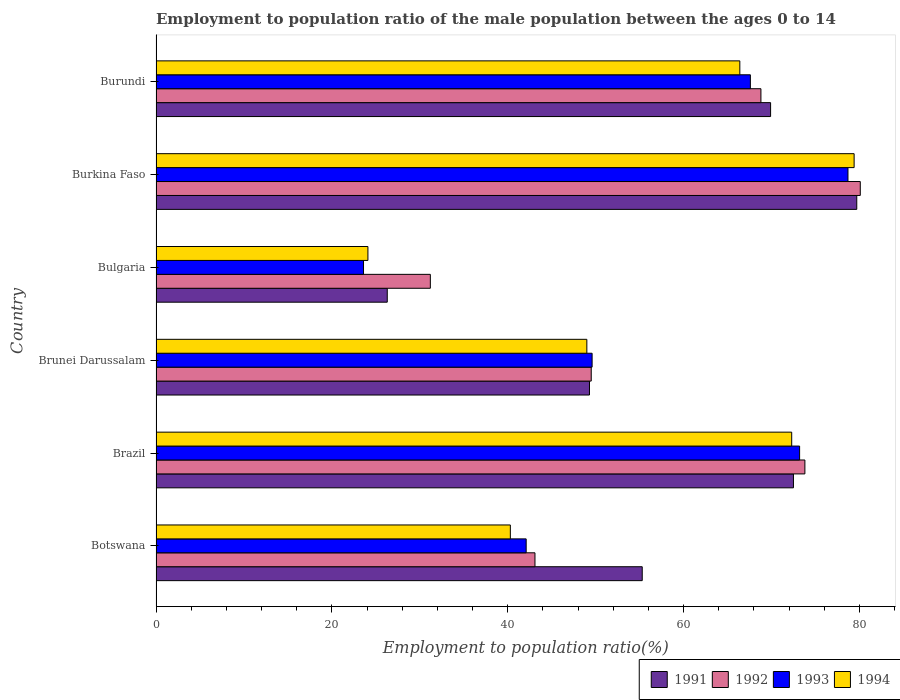Are the number of bars per tick equal to the number of legend labels?
Your answer should be very brief. Yes. How many bars are there on the 2nd tick from the top?
Offer a very short reply. 4. In how many cases, is the number of bars for a given country not equal to the number of legend labels?
Give a very brief answer. 0. What is the employment to population ratio in 1994 in Burundi?
Offer a very short reply. 66.4. Across all countries, what is the maximum employment to population ratio in 1991?
Your answer should be compact. 79.7. Across all countries, what is the minimum employment to population ratio in 1994?
Your response must be concise. 24.1. In which country was the employment to population ratio in 1994 maximum?
Your response must be concise. Burkina Faso. What is the total employment to population ratio in 1992 in the graph?
Offer a terse response. 346.5. What is the difference between the employment to population ratio in 1992 in Bulgaria and that in Burkina Faso?
Offer a very short reply. -48.9. What is the difference between the employment to population ratio in 1994 in Botswana and the employment to population ratio in 1992 in Brazil?
Offer a terse response. -33.5. What is the average employment to population ratio in 1992 per country?
Offer a very short reply. 57.75. What is the difference between the employment to population ratio in 1992 and employment to population ratio in 1994 in Burkina Faso?
Make the answer very short. 0.7. In how many countries, is the employment to population ratio in 1994 greater than 16 %?
Ensure brevity in your answer.  6. What is the ratio of the employment to population ratio in 1994 in Burkina Faso to that in Burundi?
Your response must be concise. 1.2. Is the employment to population ratio in 1993 in Botswana less than that in Bulgaria?
Your response must be concise. No. What is the difference between the highest and the second highest employment to population ratio in 1992?
Ensure brevity in your answer.  6.3. What is the difference between the highest and the lowest employment to population ratio in 1992?
Provide a short and direct response. 48.9. Is the sum of the employment to population ratio in 1994 in Brunei Darussalam and Burundi greater than the maximum employment to population ratio in 1992 across all countries?
Provide a short and direct response. Yes. What does the 2nd bar from the bottom in Brunei Darussalam represents?
Keep it short and to the point. 1992. Is it the case that in every country, the sum of the employment to population ratio in 1992 and employment to population ratio in 1994 is greater than the employment to population ratio in 1993?
Make the answer very short. Yes. How many bars are there?
Give a very brief answer. 24. How many countries are there in the graph?
Keep it short and to the point. 6. Are the values on the major ticks of X-axis written in scientific E-notation?
Make the answer very short. No. Does the graph contain any zero values?
Your response must be concise. No. Does the graph contain grids?
Offer a very short reply. No. Where does the legend appear in the graph?
Provide a short and direct response. Bottom right. How many legend labels are there?
Ensure brevity in your answer.  4. How are the legend labels stacked?
Your answer should be very brief. Horizontal. What is the title of the graph?
Your answer should be very brief. Employment to population ratio of the male population between the ages 0 to 14. Does "1969" appear as one of the legend labels in the graph?
Make the answer very short. No. What is the label or title of the Y-axis?
Offer a very short reply. Country. What is the Employment to population ratio(%) in 1991 in Botswana?
Make the answer very short. 55.3. What is the Employment to population ratio(%) in 1992 in Botswana?
Make the answer very short. 43.1. What is the Employment to population ratio(%) in 1993 in Botswana?
Ensure brevity in your answer.  42.1. What is the Employment to population ratio(%) of 1994 in Botswana?
Your answer should be very brief. 40.3. What is the Employment to population ratio(%) in 1991 in Brazil?
Your response must be concise. 72.5. What is the Employment to population ratio(%) in 1992 in Brazil?
Your answer should be compact. 73.8. What is the Employment to population ratio(%) of 1993 in Brazil?
Your answer should be very brief. 73.2. What is the Employment to population ratio(%) of 1994 in Brazil?
Ensure brevity in your answer.  72.3. What is the Employment to population ratio(%) in 1991 in Brunei Darussalam?
Provide a short and direct response. 49.3. What is the Employment to population ratio(%) of 1992 in Brunei Darussalam?
Offer a very short reply. 49.5. What is the Employment to population ratio(%) of 1993 in Brunei Darussalam?
Your answer should be very brief. 49.6. What is the Employment to population ratio(%) in 1994 in Brunei Darussalam?
Give a very brief answer. 49. What is the Employment to population ratio(%) in 1991 in Bulgaria?
Your answer should be very brief. 26.3. What is the Employment to population ratio(%) in 1992 in Bulgaria?
Make the answer very short. 31.2. What is the Employment to population ratio(%) in 1993 in Bulgaria?
Your response must be concise. 23.6. What is the Employment to population ratio(%) of 1994 in Bulgaria?
Your response must be concise. 24.1. What is the Employment to population ratio(%) of 1991 in Burkina Faso?
Provide a succinct answer. 79.7. What is the Employment to population ratio(%) in 1992 in Burkina Faso?
Keep it short and to the point. 80.1. What is the Employment to population ratio(%) of 1993 in Burkina Faso?
Keep it short and to the point. 78.7. What is the Employment to population ratio(%) in 1994 in Burkina Faso?
Make the answer very short. 79.4. What is the Employment to population ratio(%) of 1991 in Burundi?
Make the answer very short. 69.9. What is the Employment to population ratio(%) in 1992 in Burundi?
Offer a terse response. 68.8. What is the Employment to population ratio(%) in 1993 in Burundi?
Give a very brief answer. 67.6. What is the Employment to population ratio(%) of 1994 in Burundi?
Ensure brevity in your answer.  66.4. Across all countries, what is the maximum Employment to population ratio(%) in 1991?
Ensure brevity in your answer.  79.7. Across all countries, what is the maximum Employment to population ratio(%) of 1992?
Your answer should be very brief. 80.1. Across all countries, what is the maximum Employment to population ratio(%) of 1993?
Your response must be concise. 78.7. Across all countries, what is the maximum Employment to population ratio(%) in 1994?
Keep it short and to the point. 79.4. Across all countries, what is the minimum Employment to population ratio(%) of 1991?
Make the answer very short. 26.3. Across all countries, what is the minimum Employment to population ratio(%) of 1992?
Your answer should be compact. 31.2. Across all countries, what is the minimum Employment to population ratio(%) of 1993?
Offer a very short reply. 23.6. Across all countries, what is the minimum Employment to population ratio(%) of 1994?
Give a very brief answer. 24.1. What is the total Employment to population ratio(%) of 1991 in the graph?
Give a very brief answer. 353. What is the total Employment to population ratio(%) of 1992 in the graph?
Provide a short and direct response. 346.5. What is the total Employment to population ratio(%) of 1993 in the graph?
Your response must be concise. 334.8. What is the total Employment to population ratio(%) in 1994 in the graph?
Your response must be concise. 331.5. What is the difference between the Employment to population ratio(%) of 1991 in Botswana and that in Brazil?
Your response must be concise. -17.2. What is the difference between the Employment to population ratio(%) of 1992 in Botswana and that in Brazil?
Provide a succinct answer. -30.7. What is the difference between the Employment to population ratio(%) in 1993 in Botswana and that in Brazil?
Your answer should be compact. -31.1. What is the difference between the Employment to population ratio(%) in 1994 in Botswana and that in Brazil?
Offer a terse response. -32. What is the difference between the Employment to population ratio(%) in 1991 in Botswana and that in Brunei Darussalam?
Give a very brief answer. 6. What is the difference between the Employment to population ratio(%) in 1992 in Botswana and that in Brunei Darussalam?
Your answer should be very brief. -6.4. What is the difference between the Employment to population ratio(%) in 1994 in Botswana and that in Brunei Darussalam?
Your answer should be compact. -8.7. What is the difference between the Employment to population ratio(%) in 1991 in Botswana and that in Bulgaria?
Keep it short and to the point. 29. What is the difference between the Employment to population ratio(%) in 1992 in Botswana and that in Bulgaria?
Offer a terse response. 11.9. What is the difference between the Employment to population ratio(%) in 1993 in Botswana and that in Bulgaria?
Provide a short and direct response. 18.5. What is the difference between the Employment to population ratio(%) in 1991 in Botswana and that in Burkina Faso?
Provide a short and direct response. -24.4. What is the difference between the Employment to population ratio(%) in 1992 in Botswana and that in Burkina Faso?
Keep it short and to the point. -37. What is the difference between the Employment to population ratio(%) of 1993 in Botswana and that in Burkina Faso?
Your response must be concise. -36.6. What is the difference between the Employment to population ratio(%) in 1994 in Botswana and that in Burkina Faso?
Offer a terse response. -39.1. What is the difference between the Employment to population ratio(%) of 1991 in Botswana and that in Burundi?
Your answer should be compact. -14.6. What is the difference between the Employment to population ratio(%) in 1992 in Botswana and that in Burundi?
Provide a succinct answer. -25.7. What is the difference between the Employment to population ratio(%) of 1993 in Botswana and that in Burundi?
Give a very brief answer. -25.5. What is the difference between the Employment to population ratio(%) in 1994 in Botswana and that in Burundi?
Ensure brevity in your answer.  -26.1. What is the difference between the Employment to population ratio(%) in 1991 in Brazil and that in Brunei Darussalam?
Provide a succinct answer. 23.2. What is the difference between the Employment to population ratio(%) in 1992 in Brazil and that in Brunei Darussalam?
Ensure brevity in your answer.  24.3. What is the difference between the Employment to population ratio(%) in 1993 in Brazil and that in Brunei Darussalam?
Your response must be concise. 23.6. What is the difference between the Employment to population ratio(%) of 1994 in Brazil and that in Brunei Darussalam?
Provide a short and direct response. 23.3. What is the difference between the Employment to population ratio(%) of 1991 in Brazil and that in Bulgaria?
Keep it short and to the point. 46.2. What is the difference between the Employment to population ratio(%) of 1992 in Brazil and that in Bulgaria?
Your answer should be very brief. 42.6. What is the difference between the Employment to population ratio(%) in 1993 in Brazil and that in Bulgaria?
Offer a very short reply. 49.6. What is the difference between the Employment to population ratio(%) in 1994 in Brazil and that in Bulgaria?
Your answer should be very brief. 48.2. What is the difference between the Employment to population ratio(%) in 1992 in Brazil and that in Burkina Faso?
Your answer should be very brief. -6.3. What is the difference between the Employment to population ratio(%) in 1993 in Brazil and that in Burkina Faso?
Your response must be concise. -5.5. What is the difference between the Employment to population ratio(%) of 1991 in Brazil and that in Burundi?
Your answer should be very brief. 2.6. What is the difference between the Employment to population ratio(%) in 1994 in Brazil and that in Burundi?
Make the answer very short. 5.9. What is the difference between the Employment to population ratio(%) of 1991 in Brunei Darussalam and that in Bulgaria?
Offer a terse response. 23. What is the difference between the Employment to population ratio(%) in 1993 in Brunei Darussalam and that in Bulgaria?
Your answer should be compact. 26. What is the difference between the Employment to population ratio(%) in 1994 in Brunei Darussalam and that in Bulgaria?
Provide a succinct answer. 24.9. What is the difference between the Employment to population ratio(%) in 1991 in Brunei Darussalam and that in Burkina Faso?
Ensure brevity in your answer.  -30.4. What is the difference between the Employment to population ratio(%) in 1992 in Brunei Darussalam and that in Burkina Faso?
Make the answer very short. -30.6. What is the difference between the Employment to population ratio(%) in 1993 in Brunei Darussalam and that in Burkina Faso?
Your answer should be very brief. -29.1. What is the difference between the Employment to population ratio(%) in 1994 in Brunei Darussalam and that in Burkina Faso?
Your answer should be compact. -30.4. What is the difference between the Employment to population ratio(%) in 1991 in Brunei Darussalam and that in Burundi?
Your response must be concise. -20.6. What is the difference between the Employment to population ratio(%) in 1992 in Brunei Darussalam and that in Burundi?
Offer a very short reply. -19.3. What is the difference between the Employment to population ratio(%) of 1993 in Brunei Darussalam and that in Burundi?
Offer a very short reply. -18. What is the difference between the Employment to population ratio(%) of 1994 in Brunei Darussalam and that in Burundi?
Provide a short and direct response. -17.4. What is the difference between the Employment to population ratio(%) of 1991 in Bulgaria and that in Burkina Faso?
Provide a short and direct response. -53.4. What is the difference between the Employment to population ratio(%) of 1992 in Bulgaria and that in Burkina Faso?
Make the answer very short. -48.9. What is the difference between the Employment to population ratio(%) of 1993 in Bulgaria and that in Burkina Faso?
Give a very brief answer. -55.1. What is the difference between the Employment to population ratio(%) of 1994 in Bulgaria and that in Burkina Faso?
Your answer should be compact. -55.3. What is the difference between the Employment to population ratio(%) in 1991 in Bulgaria and that in Burundi?
Keep it short and to the point. -43.6. What is the difference between the Employment to population ratio(%) in 1992 in Bulgaria and that in Burundi?
Your response must be concise. -37.6. What is the difference between the Employment to population ratio(%) in 1993 in Bulgaria and that in Burundi?
Offer a terse response. -44. What is the difference between the Employment to population ratio(%) in 1994 in Bulgaria and that in Burundi?
Your response must be concise. -42.3. What is the difference between the Employment to population ratio(%) in 1991 in Burkina Faso and that in Burundi?
Your answer should be compact. 9.8. What is the difference between the Employment to population ratio(%) of 1992 in Burkina Faso and that in Burundi?
Offer a terse response. 11.3. What is the difference between the Employment to population ratio(%) of 1991 in Botswana and the Employment to population ratio(%) of 1992 in Brazil?
Make the answer very short. -18.5. What is the difference between the Employment to population ratio(%) in 1991 in Botswana and the Employment to population ratio(%) in 1993 in Brazil?
Offer a terse response. -17.9. What is the difference between the Employment to population ratio(%) of 1992 in Botswana and the Employment to population ratio(%) of 1993 in Brazil?
Keep it short and to the point. -30.1. What is the difference between the Employment to population ratio(%) in 1992 in Botswana and the Employment to population ratio(%) in 1994 in Brazil?
Keep it short and to the point. -29.2. What is the difference between the Employment to population ratio(%) of 1993 in Botswana and the Employment to population ratio(%) of 1994 in Brazil?
Offer a terse response. -30.2. What is the difference between the Employment to population ratio(%) of 1991 in Botswana and the Employment to population ratio(%) of 1994 in Brunei Darussalam?
Your response must be concise. 6.3. What is the difference between the Employment to population ratio(%) of 1992 in Botswana and the Employment to population ratio(%) of 1993 in Brunei Darussalam?
Offer a terse response. -6.5. What is the difference between the Employment to population ratio(%) of 1992 in Botswana and the Employment to population ratio(%) of 1994 in Brunei Darussalam?
Ensure brevity in your answer.  -5.9. What is the difference between the Employment to population ratio(%) in 1991 in Botswana and the Employment to population ratio(%) in 1992 in Bulgaria?
Provide a succinct answer. 24.1. What is the difference between the Employment to population ratio(%) in 1991 in Botswana and the Employment to population ratio(%) in 1993 in Bulgaria?
Ensure brevity in your answer.  31.7. What is the difference between the Employment to population ratio(%) of 1991 in Botswana and the Employment to population ratio(%) of 1994 in Bulgaria?
Provide a succinct answer. 31.2. What is the difference between the Employment to population ratio(%) in 1992 in Botswana and the Employment to population ratio(%) in 1993 in Bulgaria?
Your answer should be very brief. 19.5. What is the difference between the Employment to population ratio(%) of 1992 in Botswana and the Employment to population ratio(%) of 1994 in Bulgaria?
Keep it short and to the point. 19. What is the difference between the Employment to population ratio(%) in 1993 in Botswana and the Employment to population ratio(%) in 1994 in Bulgaria?
Provide a short and direct response. 18. What is the difference between the Employment to population ratio(%) of 1991 in Botswana and the Employment to population ratio(%) of 1992 in Burkina Faso?
Your answer should be compact. -24.8. What is the difference between the Employment to population ratio(%) in 1991 in Botswana and the Employment to population ratio(%) in 1993 in Burkina Faso?
Give a very brief answer. -23.4. What is the difference between the Employment to population ratio(%) of 1991 in Botswana and the Employment to population ratio(%) of 1994 in Burkina Faso?
Your answer should be compact. -24.1. What is the difference between the Employment to population ratio(%) of 1992 in Botswana and the Employment to population ratio(%) of 1993 in Burkina Faso?
Your response must be concise. -35.6. What is the difference between the Employment to population ratio(%) of 1992 in Botswana and the Employment to population ratio(%) of 1994 in Burkina Faso?
Offer a very short reply. -36.3. What is the difference between the Employment to population ratio(%) in 1993 in Botswana and the Employment to population ratio(%) in 1994 in Burkina Faso?
Keep it short and to the point. -37.3. What is the difference between the Employment to population ratio(%) of 1991 in Botswana and the Employment to population ratio(%) of 1993 in Burundi?
Keep it short and to the point. -12.3. What is the difference between the Employment to population ratio(%) of 1991 in Botswana and the Employment to population ratio(%) of 1994 in Burundi?
Keep it short and to the point. -11.1. What is the difference between the Employment to population ratio(%) of 1992 in Botswana and the Employment to population ratio(%) of 1993 in Burundi?
Your response must be concise. -24.5. What is the difference between the Employment to population ratio(%) in 1992 in Botswana and the Employment to population ratio(%) in 1994 in Burundi?
Your response must be concise. -23.3. What is the difference between the Employment to population ratio(%) in 1993 in Botswana and the Employment to population ratio(%) in 1994 in Burundi?
Make the answer very short. -24.3. What is the difference between the Employment to population ratio(%) of 1991 in Brazil and the Employment to population ratio(%) of 1993 in Brunei Darussalam?
Offer a terse response. 22.9. What is the difference between the Employment to population ratio(%) in 1992 in Brazil and the Employment to population ratio(%) in 1993 in Brunei Darussalam?
Offer a terse response. 24.2. What is the difference between the Employment to population ratio(%) in 1992 in Brazil and the Employment to population ratio(%) in 1994 in Brunei Darussalam?
Provide a succinct answer. 24.8. What is the difference between the Employment to population ratio(%) of 1993 in Brazil and the Employment to population ratio(%) of 1994 in Brunei Darussalam?
Offer a terse response. 24.2. What is the difference between the Employment to population ratio(%) of 1991 in Brazil and the Employment to population ratio(%) of 1992 in Bulgaria?
Provide a short and direct response. 41.3. What is the difference between the Employment to population ratio(%) in 1991 in Brazil and the Employment to population ratio(%) in 1993 in Bulgaria?
Your response must be concise. 48.9. What is the difference between the Employment to population ratio(%) in 1991 in Brazil and the Employment to population ratio(%) in 1994 in Bulgaria?
Ensure brevity in your answer.  48.4. What is the difference between the Employment to population ratio(%) of 1992 in Brazil and the Employment to population ratio(%) of 1993 in Bulgaria?
Your answer should be compact. 50.2. What is the difference between the Employment to population ratio(%) of 1992 in Brazil and the Employment to population ratio(%) of 1994 in Bulgaria?
Give a very brief answer. 49.7. What is the difference between the Employment to population ratio(%) of 1993 in Brazil and the Employment to population ratio(%) of 1994 in Bulgaria?
Provide a succinct answer. 49.1. What is the difference between the Employment to population ratio(%) in 1991 in Brazil and the Employment to population ratio(%) in 1993 in Burkina Faso?
Your response must be concise. -6.2. What is the difference between the Employment to population ratio(%) of 1991 in Brazil and the Employment to population ratio(%) of 1994 in Burkina Faso?
Offer a terse response. -6.9. What is the difference between the Employment to population ratio(%) of 1992 in Brazil and the Employment to population ratio(%) of 1994 in Burkina Faso?
Ensure brevity in your answer.  -5.6. What is the difference between the Employment to population ratio(%) of 1991 in Brazil and the Employment to population ratio(%) of 1994 in Burundi?
Offer a very short reply. 6.1. What is the difference between the Employment to population ratio(%) in 1992 in Brazil and the Employment to population ratio(%) in 1993 in Burundi?
Keep it short and to the point. 6.2. What is the difference between the Employment to population ratio(%) in 1991 in Brunei Darussalam and the Employment to population ratio(%) in 1993 in Bulgaria?
Give a very brief answer. 25.7. What is the difference between the Employment to population ratio(%) in 1991 in Brunei Darussalam and the Employment to population ratio(%) in 1994 in Bulgaria?
Your response must be concise. 25.2. What is the difference between the Employment to population ratio(%) in 1992 in Brunei Darussalam and the Employment to population ratio(%) in 1993 in Bulgaria?
Offer a very short reply. 25.9. What is the difference between the Employment to population ratio(%) in 1992 in Brunei Darussalam and the Employment to population ratio(%) in 1994 in Bulgaria?
Your answer should be very brief. 25.4. What is the difference between the Employment to population ratio(%) in 1991 in Brunei Darussalam and the Employment to population ratio(%) in 1992 in Burkina Faso?
Keep it short and to the point. -30.8. What is the difference between the Employment to population ratio(%) of 1991 in Brunei Darussalam and the Employment to population ratio(%) of 1993 in Burkina Faso?
Ensure brevity in your answer.  -29.4. What is the difference between the Employment to population ratio(%) of 1991 in Brunei Darussalam and the Employment to population ratio(%) of 1994 in Burkina Faso?
Keep it short and to the point. -30.1. What is the difference between the Employment to population ratio(%) in 1992 in Brunei Darussalam and the Employment to population ratio(%) in 1993 in Burkina Faso?
Offer a terse response. -29.2. What is the difference between the Employment to population ratio(%) of 1992 in Brunei Darussalam and the Employment to population ratio(%) of 1994 in Burkina Faso?
Make the answer very short. -29.9. What is the difference between the Employment to population ratio(%) of 1993 in Brunei Darussalam and the Employment to population ratio(%) of 1994 in Burkina Faso?
Your answer should be very brief. -29.8. What is the difference between the Employment to population ratio(%) in 1991 in Brunei Darussalam and the Employment to population ratio(%) in 1992 in Burundi?
Your answer should be compact. -19.5. What is the difference between the Employment to population ratio(%) of 1991 in Brunei Darussalam and the Employment to population ratio(%) of 1993 in Burundi?
Provide a short and direct response. -18.3. What is the difference between the Employment to population ratio(%) of 1991 in Brunei Darussalam and the Employment to population ratio(%) of 1994 in Burundi?
Ensure brevity in your answer.  -17.1. What is the difference between the Employment to population ratio(%) in 1992 in Brunei Darussalam and the Employment to population ratio(%) in 1993 in Burundi?
Your answer should be very brief. -18.1. What is the difference between the Employment to population ratio(%) of 1992 in Brunei Darussalam and the Employment to population ratio(%) of 1994 in Burundi?
Your response must be concise. -16.9. What is the difference between the Employment to population ratio(%) of 1993 in Brunei Darussalam and the Employment to population ratio(%) of 1994 in Burundi?
Offer a very short reply. -16.8. What is the difference between the Employment to population ratio(%) in 1991 in Bulgaria and the Employment to population ratio(%) in 1992 in Burkina Faso?
Ensure brevity in your answer.  -53.8. What is the difference between the Employment to population ratio(%) of 1991 in Bulgaria and the Employment to population ratio(%) of 1993 in Burkina Faso?
Keep it short and to the point. -52.4. What is the difference between the Employment to population ratio(%) of 1991 in Bulgaria and the Employment to population ratio(%) of 1994 in Burkina Faso?
Ensure brevity in your answer.  -53.1. What is the difference between the Employment to population ratio(%) of 1992 in Bulgaria and the Employment to population ratio(%) of 1993 in Burkina Faso?
Ensure brevity in your answer.  -47.5. What is the difference between the Employment to population ratio(%) in 1992 in Bulgaria and the Employment to population ratio(%) in 1994 in Burkina Faso?
Offer a terse response. -48.2. What is the difference between the Employment to population ratio(%) in 1993 in Bulgaria and the Employment to population ratio(%) in 1994 in Burkina Faso?
Keep it short and to the point. -55.8. What is the difference between the Employment to population ratio(%) of 1991 in Bulgaria and the Employment to population ratio(%) of 1992 in Burundi?
Keep it short and to the point. -42.5. What is the difference between the Employment to population ratio(%) of 1991 in Bulgaria and the Employment to population ratio(%) of 1993 in Burundi?
Your answer should be compact. -41.3. What is the difference between the Employment to population ratio(%) in 1991 in Bulgaria and the Employment to population ratio(%) in 1994 in Burundi?
Your answer should be very brief. -40.1. What is the difference between the Employment to population ratio(%) of 1992 in Bulgaria and the Employment to population ratio(%) of 1993 in Burundi?
Keep it short and to the point. -36.4. What is the difference between the Employment to population ratio(%) of 1992 in Bulgaria and the Employment to population ratio(%) of 1994 in Burundi?
Provide a short and direct response. -35.2. What is the difference between the Employment to population ratio(%) of 1993 in Bulgaria and the Employment to population ratio(%) of 1994 in Burundi?
Offer a terse response. -42.8. What is the difference between the Employment to population ratio(%) in 1991 in Burkina Faso and the Employment to population ratio(%) in 1992 in Burundi?
Keep it short and to the point. 10.9. What is the average Employment to population ratio(%) of 1991 per country?
Offer a terse response. 58.83. What is the average Employment to population ratio(%) in 1992 per country?
Provide a short and direct response. 57.75. What is the average Employment to population ratio(%) of 1993 per country?
Your answer should be very brief. 55.8. What is the average Employment to population ratio(%) in 1994 per country?
Keep it short and to the point. 55.25. What is the difference between the Employment to population ratio(%) in 1991 and Employment to population ratio(%) in 1992 in Botswana?
Your answer should be very brief. 12.2. What is the difference between the Employment to population ratio(%) in 1991 and Employment to population ratio(%) in 1994 in Botswana?
Provide a succinct answer. 15. What is the difference between the Employment to population ratio(%) of 1992 and Employment to population ratio(%) of 1993 in Botswana?
Keep it short and to the point. 1. What is the difference between the Employment to population ratio(%) in 1992 and Employment to population ratio(%) in 1994 in Botswana?
Ensure brevity in your answer.  2.8. What is the difference between the Employment to population ratio(%) in 1991 and Employment to population ratio(%) in 1992 in Brazil?
Offer a terse response. -1.3. What is the difference between the Employment to population ratio(%) of 1991 and Employment to population ratio(%) of 1992 in Brunei Darussalam?
Your answer should be compact. -0.2. What is the difference between the Employment to population ratio(%) of 1991 and Employment to population ratio(%) of 1993 in Brunei Darussalam?
Your response must be concise. -0.3. What is the difference between the Employment to population ratio(%) in 1992 and Employment to population ratio(%) in 1993 in Brunei Darussalam?
Make the answer very short. -0.1. What is the difference between the Employment to population ratio(%) of 1992 and Employment to population ratio(%) of 1994 in Brunei Darussalam?
Your answer should be very brief. 0.5. What is the difference between the Employment to population ratio(%) in 1993 and Employment to population ratio(%) in 1994 in Brunei Darussalam?
Keep it short and to the point. 0.6. What is the difference between the Employment to population ratio(%) of 1992 and Employment to population ratio(%) of 1993 in Bulgaria?
Your answer should be compact. 7.6. What is the difference between the Employment to population ratio(%) in 1992 and Employment to population ratio(%) in 1994 in Bulgaria?
Make the answer very short. 7.1. What is the difference between the Employment to population ratio(%) in 1991 and Employment to population ratio(%) in 1992 in Burkina Faso?
Ensure brevity in your answer.  -0.4. What is the difference between the Employment to population ratio(%) of 1991 and Employment to population ratio(%) of 1994 in Burkina Faso?
Give a very brief answer. 0.3. What is the difference between the Employment to population ratio(%) of 1991 and Employment to population ratio(%) of 1993 in Burundi?
Your answer should be compact. 2.3. What is the ratio of the Employment to population ratio(%) in 1991 in Botswana to that in Brazil?
Ensure brevity in your answer.  0.76. What is the ratio of the Employment to population ratio(%) of 1992 in Botswana to that in Brazil?
Offer a terse response. 0.58. What is the ratio of the Employment to population ratio(%) in 1993 in Botswana to that in Brazil?
Ensure brevity in your answer.  0.58. What is the ratio of the Employment to population ratio(%) in 1994 in Botswana to that in Brazil?
Your answer should be very brief. 0.56. What is the ratio of the Employment to population ratio(%) of 1991 in Botswana to that in Brunei Darussalam?
Ensure brevity in your answer.  1.12. What is the ratio of the Employment to population ratio(%) of 1992 in Botswana to that in Brunei Darussalam?
Make the answer very short. 0.87. What is the ratio of the Employment to population ratio(%) of 1993 in Botswana to that in Brunei Darussalam?
Ensure brevity in your answer.  0.85. What is the ratio of the Employment to population ratio(%) of 1994 in Botswana to that in Brunei Darussalam?
Offer a very short reply. 0.82. What is the ratio of the Employment to population ratio(%) of 1991 in Botswana to that in Bulgaria?
Give a very brief answer. 2.1. What is the ratio of the Employment to population ratio(%) of 1992 in Botswana to that in Bulgaria?
Your answer should be compact. 1.38. What is the ratio of the Employment to population ratio(%) in 1993 in Botswana to that in Bulgaria?
Keep it short and to the point. 1.78. What is the ratio of the Employment to population ratio(%) in 1994 in Botswana to that in Bulgaria?
Give a very brief answer. 1.67. What is the ratio of the Employment to population ratio(%) in 1991 in Botswana to that in Burkina Faso?
Make the answer very short. 0.69. What is the ratio of the Employment to population ratio(%) of 1992 in Botswana to that in Burkina Faso?
Offer a terse response. 0.54. What is the ratio of the Employment to population ratio(%) of 1993 in Botswana to that in Burkina Faso?
Give a very brief answer. 0.53. What is the ratio of the Employment to population ratio(%) of 1994 in Botswana to that in Burkina Faso?
Your response must be concise. 0.51. What is the ratio of the Employment to population ratio(%) in 1991 in Botswana to that in Burundi?
Your answer should be compact. 0.79. What is the ratio of the Employment to population ratio(%) of 1992 in Botswana to that in Burundi?
Offer a very short reply. 0.63. What is the ratio of the Employment to population ratio(%) of 1993 in Botswana to that in Burundi?
Offer a very short reply. 0.62. What is the ratio of the Employment to population ratio(%) in 1994 in Botswana to that in Burundi?
Your answer should be compact. 0.61. What is the ratio of the Employment to population ratio(%) of 1991 in Brazil to that in Brunei Darussalam?
Provide a succinct answer. 1.47. What is the ratio of the Employment to population ratio(%) in 1992 in Brazil to that in Brunei Darussalam?
Ensure brevity in your answer.  1.49. What is the ratio of the Employment to population ratio(%) in 1993 in Brazil to that in Brunei Darussalam?
Offer a very short reply. 1.48. What is the ratio of the Employment to population ratio(%) in 1994 in Brazil to that in Brunei Darussalam?
Provide a succinct answer. 1.48. What is the ratio of the Employment to population ratio(%) of 1991 in Brazil to that in Bulgaria?
Offer a terse response. 2.76. What is the ratio of the Employment to population ratio(%) of 1992 in Brazil to that in Bulgaria?
Your response must be concise. 2.37. What is the ratio of the Employment to population ratio(%) of 1993 in Brazil to that in Bulgaria?
Your answer should be compact. 3.1. What is the ratio of the Employment to population ratio(%) of 1994 in Brazil to that in Bulgaria?
Provide a short and direct response. 3. What is the ratio of the Employment to population ratio(%) in 1991 in Brazil to that in Burkina Faso?
Give a very brief answer. 0.91. What is the ratio of the Employment to population ratio(%) in 1992 in Brazil to that in Burkina Faso?
Your answer should be very brief. 0.92. What is the ratio of the Employment to population ratio(%) of 1993 in Brazil to that in Burkina Faso?
Offer a very short reply. 0.93. What is the ratio of the Employment to population ratio(%) in 1994 in Brazil to that in Burkina Faso?
Offer a terse response. 0.91. What is the ratio of the Employment to population ratio(%) in 1991 in Brazil to that in Burundi?
Provide a short and direct response. 1.04. What is the ratio of the Employment to population ratio(%) of 1992 in Brazil to that in Burundi?
Your response must be concise. 1.07. What is the ratio of the Employment to population ratio(%) of 1993 in Brazil to that in Burundi?
Your answer should be very brief. 1.08. What is the ratio of the Employment to population ratio(%) in 1994 in Brazil to that in Burundi?
Your answer should be very brief. 1.09. What is the ratio of the Employment to population ratio(%) of 1991 in Brunei Darussalam to that in Bulgaria?
Your answer should be compact. 1.87. What is the ratio of the Employment to population ratio(%) of 1992 in Brunei Darussalam to that in Bulgaria?
Give a very brief answer. 1.59. What is the ratio of the Employment to population ratio(%) of 1993 in Brunei Darussalam to that in Bulgaria?
Ensure brevity in your answer.  2.1. What is the ratio of the Employment to population ratio(%) in 1994 in Brunei Darussalam to that in Bulgaria?
Offer a very short reply. 2.03. What is the ratio of the Employment to population ratio(%) in 1991 in Brunei Darussalam to that in Burkina Faso?
Make the answer very short. 0.62. What is the ratio of the Employment to population ratio(%) of 1992 in Brunei Darussalam to that in Burkina Faso?
Give a very brief answer. 0.62. What is the ratio of the Employment to population ratio(%) in 1993 in Brunei Darussalam to that in Burkina Faso?
Offer a very short reply. 0.63. What is the ratio of the Employment to population ratio(%) in 1994 in Brunei Darussalam to that in Burkina Faso?
Ensure brevity in your answer.  0.62. What is the ratio of the Employment to population ratio(%) of 1991 in Brunei Darussalam to that in Burundi?
Provide a short and direct response. 0.71. What is the ratio of the Employment to population ratio(%) in 1992 in Brunei Darussalam to that in Burundi?
Provide a succinct answer. 0.72. What is the ratio of the Employment to population ratio(%) in 1993 in Brunei Darussalam to that in Burundi?
Give a very brief answer. 0.73. What is the ratio of the Employment to population ratio(%) of 1994 in Brunei Darussalam to that in Burundi?
Offer a very short reply. 0.74. What is the ratio of the Employment to population ratio(%) in 1991 in Bulgaria to that in Burkina Faso?
Provide a succinct answer. 0.33. What is the ratio of the Employment to population ratio(%) of 1992 in Bulgaria to that in Burkina Faso?
Keep it short and to the point. 0.39. What is the ratio of the Employment to population ratio(%) in 1993 in Bulgaria to that in Burkina Faso?
Your answer should be very brief. 0.3. What is the ratio of the Employment to population ratio(%) in 1994 in Bulgaria to that in Burkina Faso?
Your answer should be very brief. 0.3. What is the ratio of the Employment to population ratio(%) in 1991 in Bulgaria to that in Burundi?
Provide a short and direct response. 0.38. What is the ratio of the Employment to population ratio(%) of 1992 in Bulgaria to that in Burundi?
Make the answer very short. 0.45. What is the ratio of the Employment to population ratio(%) in 1993 in Bulgaria to that in Burundi?
Offer a very short reply. 0.35. What is the ratio of the Employment to population ratio(%) in 1994 in Bulgaria to that in Burundi?
Offer a terse response. 0.36. What is the ratio of the Employment to population ratio(%) in 1991 in Burkina Faso to that in Burundi?
Ensure brevity in your answer.  1.14. What is the ratio of the Employment to population ratio(%) in 1992 in Burkina Faso to that in Burundi?
Offer a terse response. 1.16. What is the ratio of the Employment to population ratio(%) of 1993 in Burkina Faso to that in Burundi?
Your answer should be compact. 1.16. What is the ratio of the Employment to population ratio(%) in 1994 in Burkina Faso to that in Burundi?
Provide a short and direct response. 1.2. What is the difference between the highest and the second highest Employment to population ratio(%) in 1993?
Offer a very short reply. 5.5. What is the difference between the highest and the second highest Employment to population ratio(%) in 1994?
Your answer should be very brief. 7.1. What is the difference between the highest and the lowest Employment to population ratio(%) of 1991?
Make the answer very short. 53.4. What is the difference between the highest and the lowest Employment to population ratio(%) in 1992?
Make the answer very short. 48.9. What is the difference between the highest and the lowest Employment to population ratio(%) in 1993?
Your response must be concise. 55.1. What is the difference between the highest and the lowest Employment to population ratio(%) of 1994?
Provide a short and direct response. 55.3. 